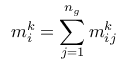<formula> <loc_0><loc_0><loc_500><loc_500>m _ { i } ^ { k } = \sum _ { j = 1 } ^ { n _ { g } } m _ { i j } ^ { k }</formula> 